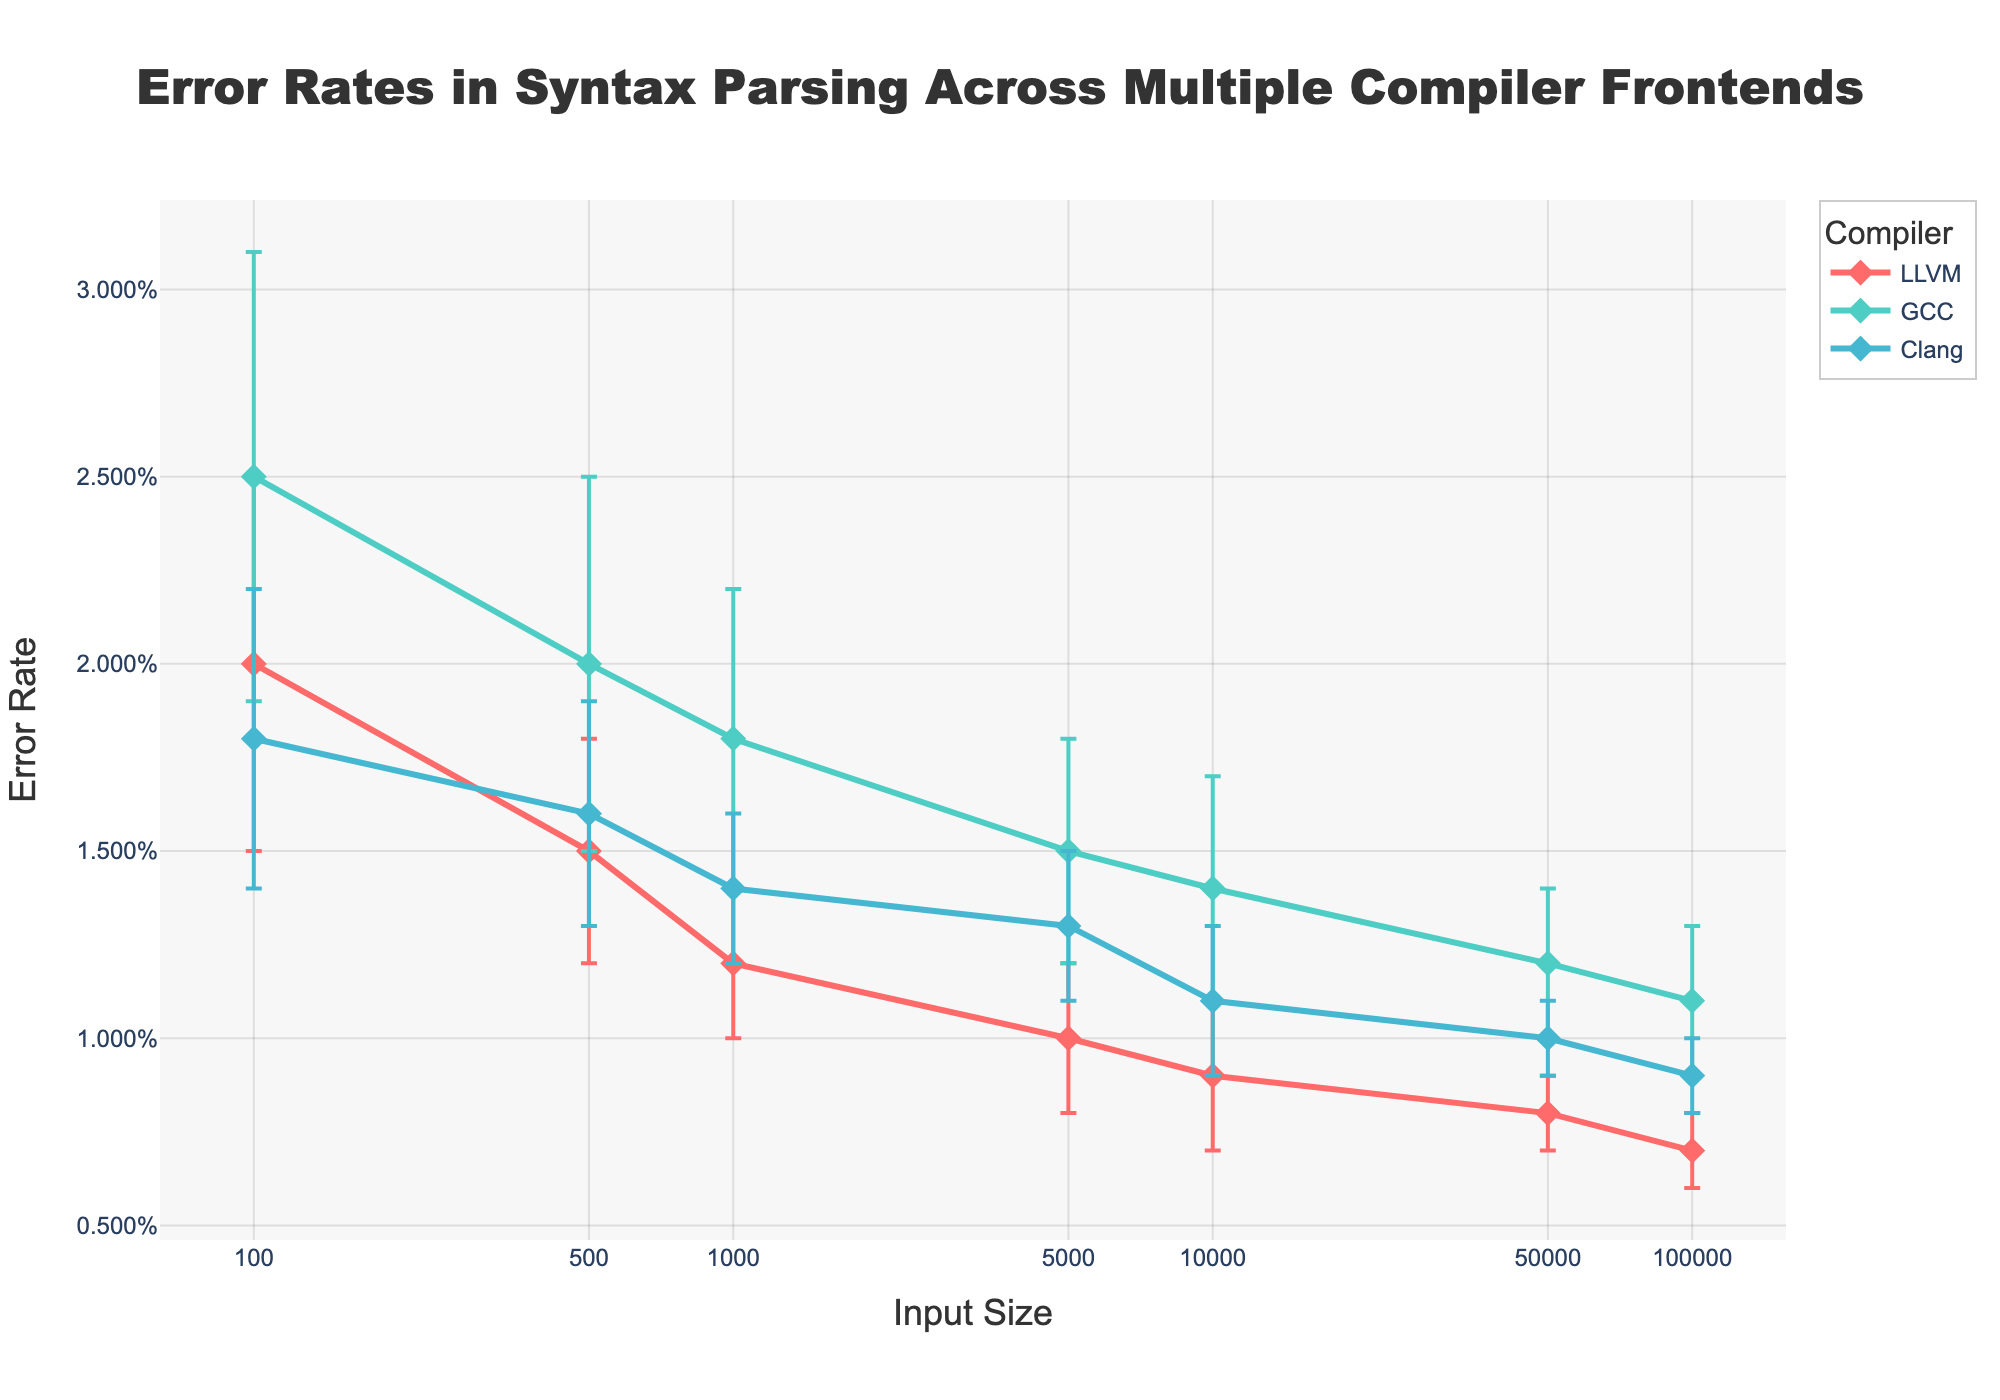what is the title of the chart? The title is usually located at the top center of the figure. In this chart, the title "Error Rates in Syntax Parsing Across Multiple Compiler Frontends" is noticeable in that position.
Answer: Error Rates in Syntax Parsing Across Multiple Compiler Frontends What is the error rate of LLVM for an input size of 10,000? Locate the line for LLVM, trace it to the point corresponding to an input size of 10,000, and observe the value on the Y-axis.
Answer: 0.009 How does GCC's error rate vary as the input size increases from 100 to 1,000? Follow the GCC line on the chart from an input size of 100 to 1,000. The error rate decreases from 0.025 to 0.018 based on the Y-axis values.
Answer: It decreases Which compiler has the lowest error rate for an input size of 50,000? For an input size of 50,000, check the Y-axis values for each of the compiler lines. LLVM has the lowest error rate at 0.008.
Answer: LLVM What is the difference in error rate between LLVM and Clang for an input size of 500? Identify the error rates for LLVM (0.015) and Clang (0.016) at an input size of 500, then subtract the smaller value from the larger one.
Answer: 0.001 What can you infer about the trend of error rates for all compilers as the input size increases? Observe the overall direction of the lines for all compilers across increasing input sizes. All error rates trend downward as input size increases.
Answer: They decrease How does Clang's error rate compare to GCC's at an input size of 1,000? Compare the Y-axis values of Clang (0.014) and GCC (0.018) at the input size of 1,000. Clang's error rate is lower.
Answer: Clang's error rate is lower What is the average error rate of GCC across all input sizes shown? Sum up the error rates for GCC at all input sizes: 0.025 + 0.02 + 0.018 + 0.015 + 0.014 + 0.012 + 0.011, and then divide by the number of data points (7). The calculation is (0.025 + 0.02 + 0.018 + 0.015 + 0.014 + 0.012 + 0.011) / 7 = 0.0164.
Answer: 0.0164 What is the standard deviation error range for LLVM at an input size of 100? Identify the error rate (0.02) and standard deviation (0.005) for LLVM at 100. The range is calculated as error rate ± standard deviation: 0.02 ± 0.005, which is [0.015, 0.025].
Answer: [0.015, 0.025] Which compiler has the smallest change in error rate from an input size of 1,000 to 100,000? Observe the error rates for each compiler at 1,000 and 100,000 sizes. Calculate the changes: LLVM (0.012 - 0.007 = 0.005), GCC (0.018 - 0.011 = 0.007), Clang (0.014 - 0.009 = 0.005). LLVM and Clang have the smallest change.
Answer: LLVM and Clang 